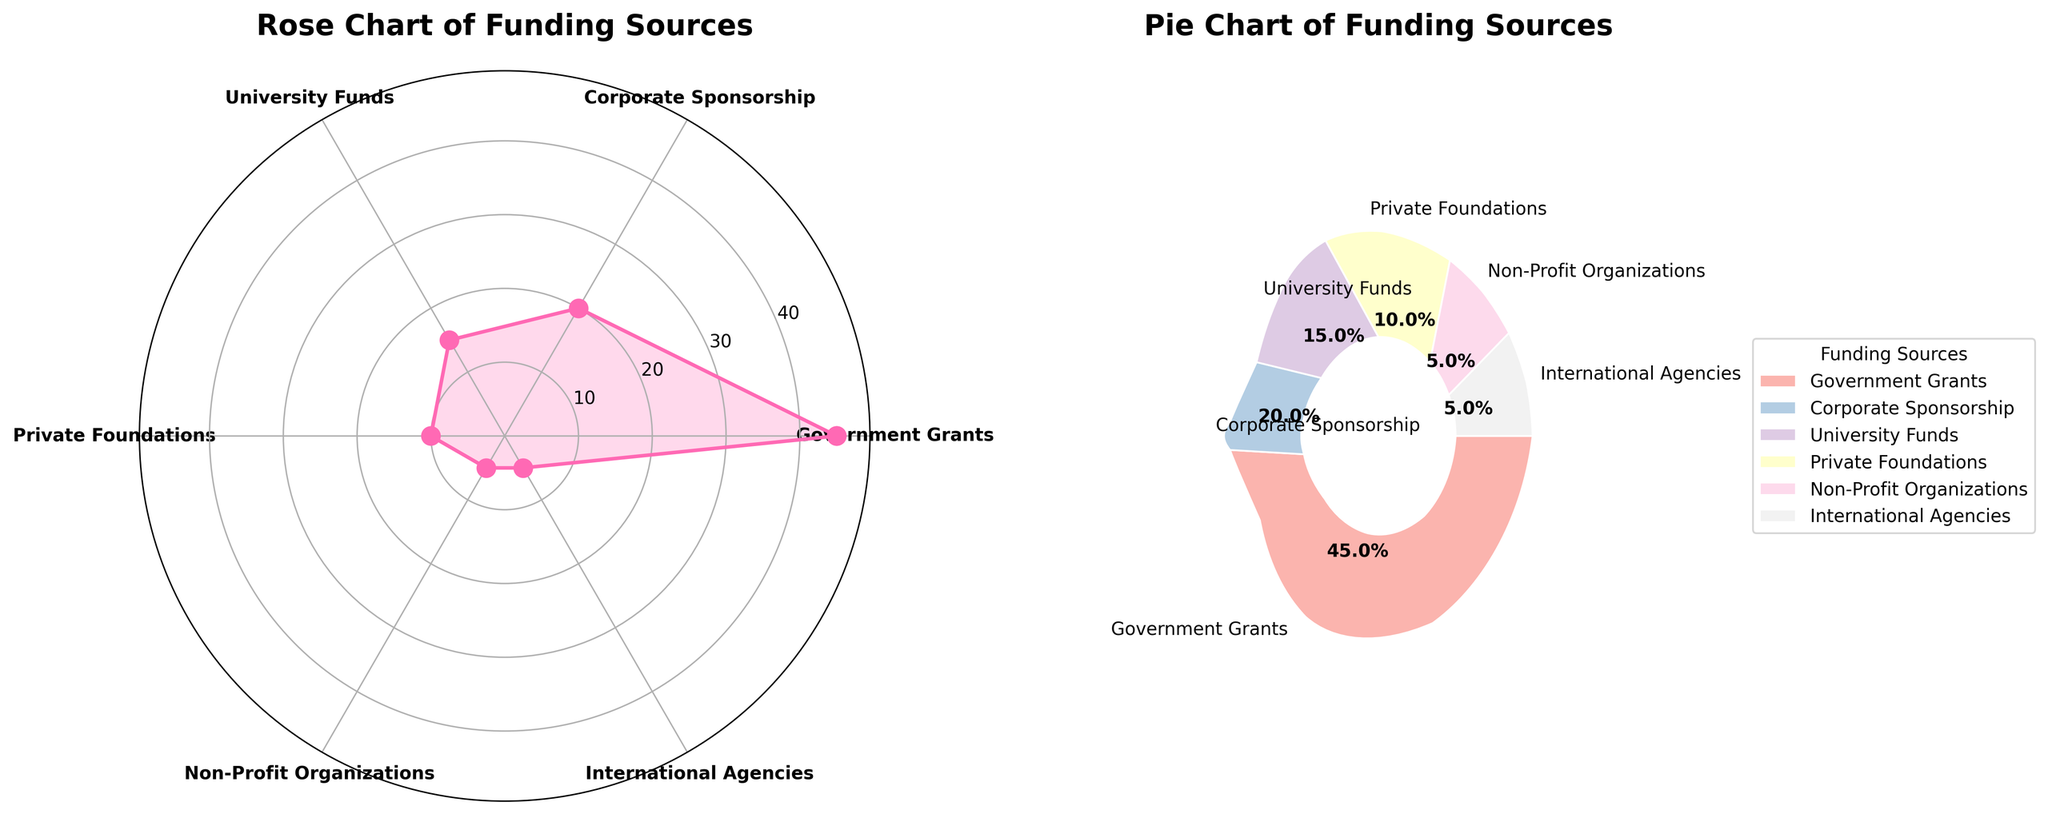what are the titles of the subplots? The titles can be found above each subplot in bold font. The first title is "Rose Chart of Funding Sources" and the second is "Pie Chart of Funding Sources".
Answer: "Rose Chart of Funding Sources" and "Pie Chart of Funding Sources" which funding source has the largest percentage in the rose chart? The rose chart uses concentration and possibly filled shapes. The largest spike is seen at the label "Government Grants", indicating the highest percentage.
Answer: Government Grants what is the combined percentage of the smallest two funding sources? The smallest two funding sources are "Non-Profit Organizations" and "International Agencies" each at 5%, thus their combined percentage is 5% + 5% = 10%.
Answer: 10% compare the funding percentages between University Funds and Corporate Sponsorship? University Funds are marked at 15% and Corporate Sponsorship at 20%. Therefore, Corporate Sponsorship is 5% higher than University Funds.
Answer: Corporate Sponsorship is 5% higher how many funding sources are represented in the rose chart? The tick marks on the rose chart separate the different sources. There are six distinct sources labeled around the chart.
Answer: Six what colors are used for the wedges in the pie chart? The pie chart applies pastel colors in a range, but the exact color names are not specified. Each wedge has different pastel shades.
Answer: Varied pastel colors what's the average percentage across all funding sources? Sum of all percentages (45+20+15+10+5+5) is 100. There are 6 funding sources, hence the average is 100/6 ≈ 16.67%.
Answer: Approximately 16.67% how does the radial extension of Government Grants in the rose chart compare to the other sources? The radial extension or the height of the spike for Government Grants is the longest, indicating the highest percentage among all funding sources.
Answer: It is the longest which funding source ranges between Private Foundations and Non-Profit Organizations in percentage? Moving sequentially, "University Funds" at 15% lies between "Private Foundations" at 10% and "Non-Profit Organizations" at 5%.
Answer: University Funds 